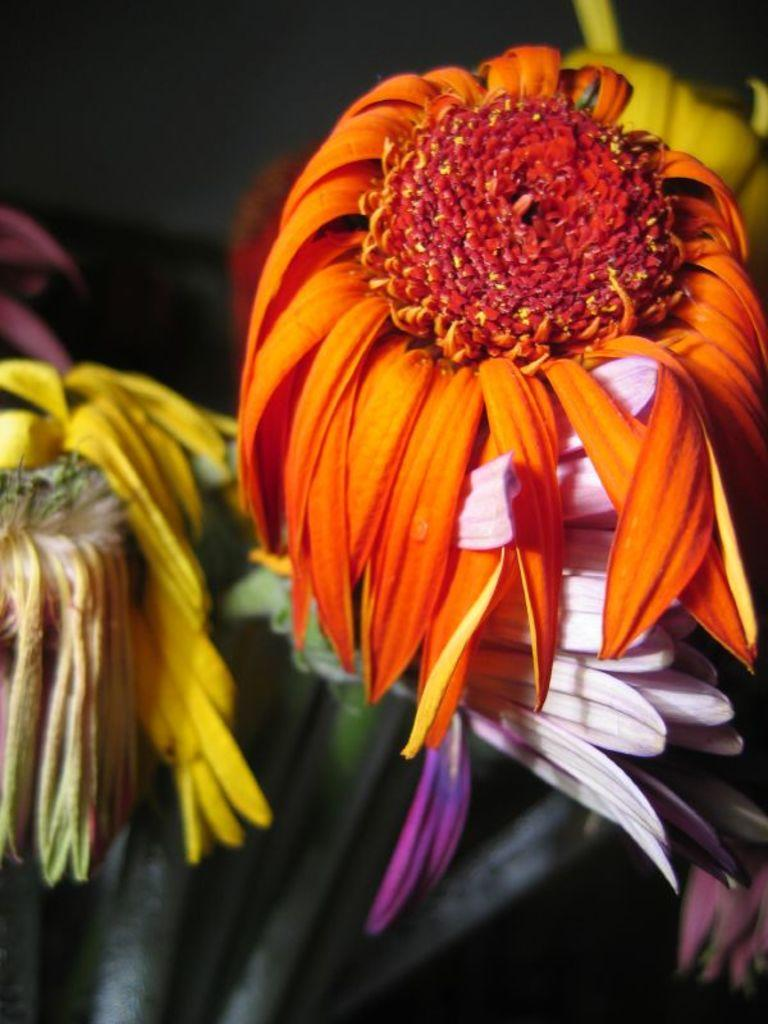What type of living organisms can be seen in the image? There are flowers in the image. Where are the flowers located? The flowers are on plants. What colors can be seen in the flowers? The flowers are in yellow, pink, white, and orange colors. What is the color of the background in the image? The background of the image is black. What type of net is being used to catch the cannon in the image? There is no net or cannon present in the image; it features flowers on plants with a black background. What color is the dress worn by the person holding the flowers in the image? There is no person or dress present in the image; it only shows flowers on plants with a black background. 